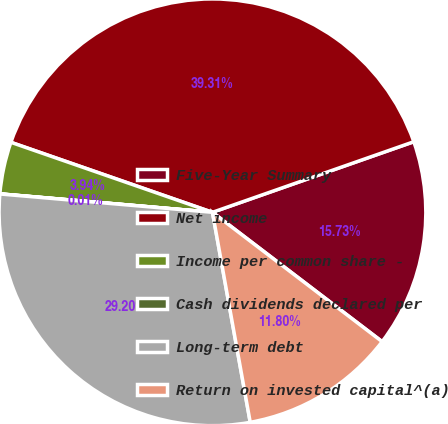Convert chart. <chart><loc_0><loc_0><loc_500><loc_500><pie_chart><fcel>Five-Year Summary<fcel>Net income<fcel>Income per common share -<fcel>Cash dividends declared per<fcel>Long-term debt<fcel>Return on invested capital^(a)<nl><fcel>15.73%<fcel>39.31%<fcel>3.94%<fcel>0.01%<fcel>29.2%<fcel>11.8%<nl></chart> 